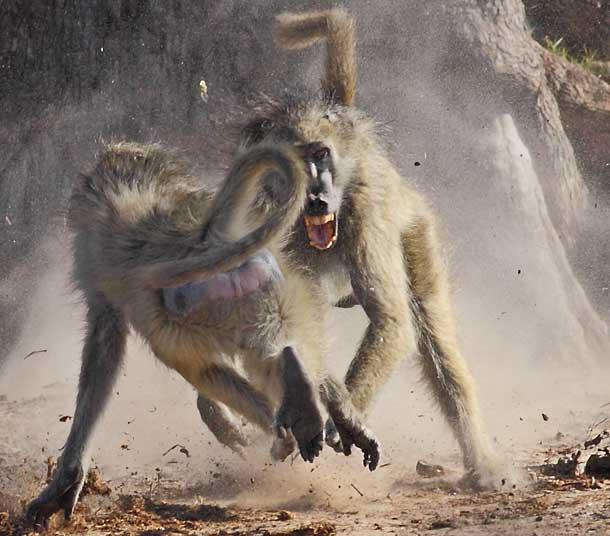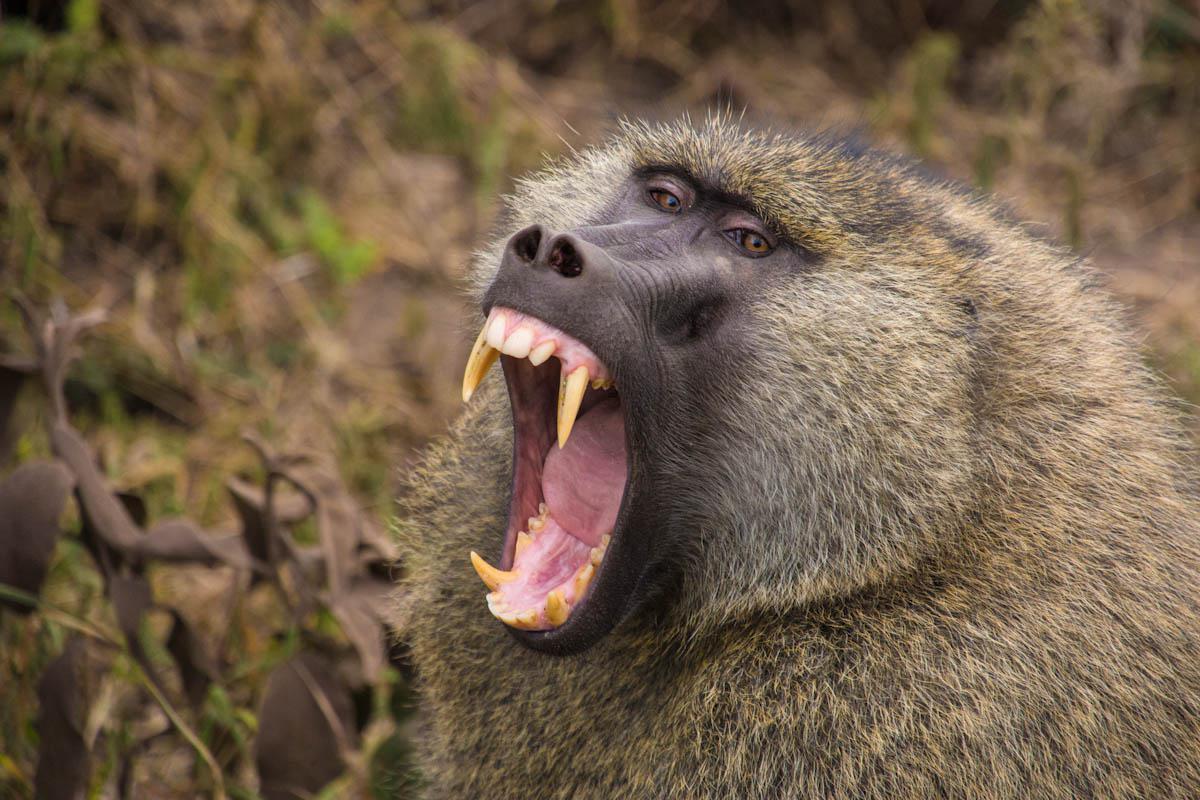The first image is the image on the left, the second image is the image on the right. Given the left and right images, does the statement "There is more than one monkey in the left image." hold true? Answer yes or no. Yes. The first image is the image on the left, the second image is the image on the right. Evaluate the accuracy of this statement regarding the images: "At least one of the animals is showing its teeth.". Is it true? Answer yes or no. Yes. 